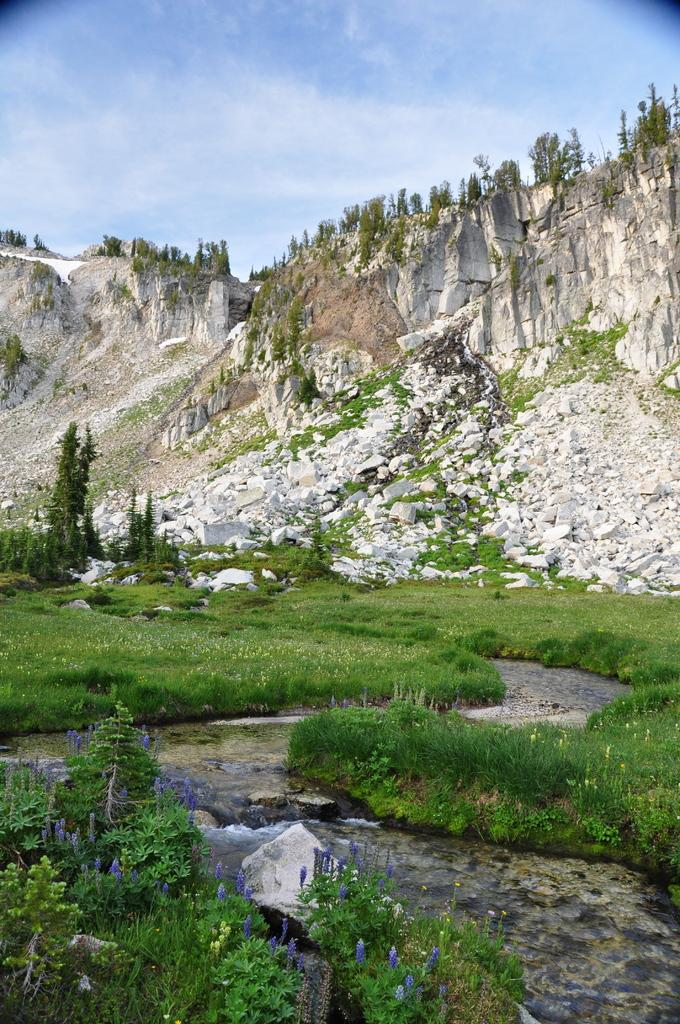What type of geological formation can be seen in the image? There are rock hills in the image. What kind of vegetation is present in the image? There are small plants with flowers and trees in the image. Is there any indication of water in the image? Yes, there is water flowing in the image. Can you tell me how many friends are laughing at the joke in the image? There is no reference to friends or a joke in the image; it features rock hills, small plants with flowers, trees, and water flowing. 